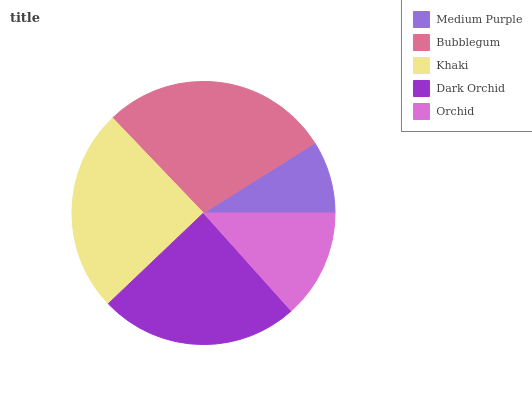Is Medium Purple the minimum?
Answer yes or no. Yes. Is Bubblegum the maximum?
Answer yes or no. Yes. Is Khaki the minimum?
Answer yes or no. No. Is Khaki the maximum?
Answer yes or no. No. Is Bubblegum greater than Khaki?
Answer yes or no. Yes. Is Khaki less than Bubblegum?
Answer yes or no. Yes. Is Khaki greater than Bubblegum?
Answer yes or no. No. Is Bubblegum less than Khaki?
Answer yes or no. No. Is Dark Orchid the high median?
Answer yes or no. Yes. Is Dark Orchid the low median?
Answer yes or no. Yes. Is Bubblegum the high median?
Answer yes or no. No. Is Medium Purple the low median?
Answer yes or no. No. 